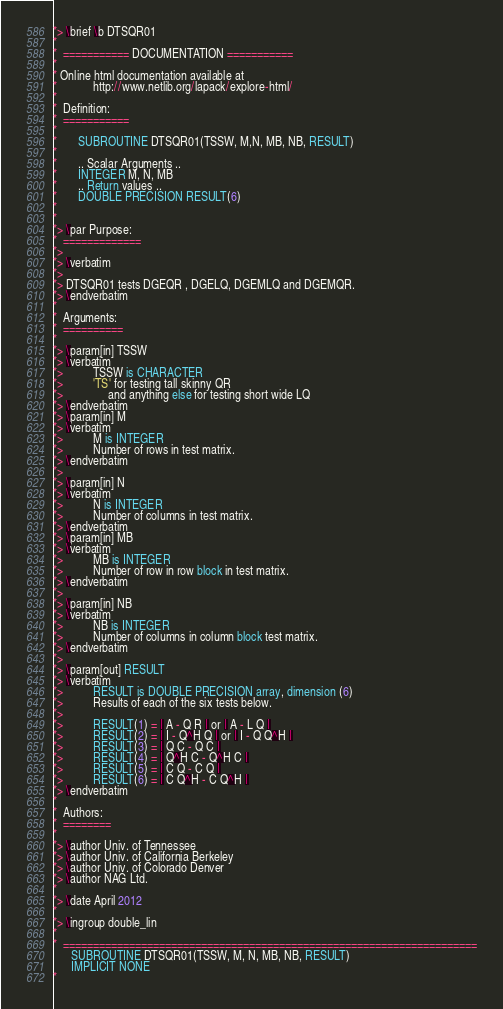Convert code to text. <code><loc_0><loc_0><loc_500><loc_500><_FORTRAN_>*> \brief \b DTSQR01
*
*  =========== DOCUMENTATION ===========
*
* Online html documentation available at
*            http://www.netlib.org/lapack/explore-html/
*
*  Definition:
*  ===========
*
*       SUBROUTINE DTSQR01(TSSW, M,N, MB, NB, RESULT)
*
*       .. Scalar Arguments ..
*       INTEGER M, N, MB
*       .. Return values ..
*       DOUBLE PRECISION RESULT(6)
*
*
*> \par Purpose:
*  =============
*>
*> \verbatim
*>
*> DTSQR01 tests DGEQR , DGELQ, DGEMLQ and DGEMQR.
*> \endverbatim
*
*  Arguments:
*  ==========
*
*> \param[in] TSSW
*> \verbatim
*>          TSSW is CHARACTER
*>          'TS' for testing tall skinny QR
*>               and anything else for testing short wide LQ
*> \endverbatim
*> \param[in] M
*> \verbatim
*>          M is INTEGER
*>          Number of rows in test matrix.
*> \endverbatim
*>
*> \param[in] N
*> \verbatim
*>          N is INTEGER
*>          Number of columns in test matrix.
*> \endverbatim
*> \param[in] MB
*> \verbatim
*>          MB is INTEGER
*>          Number of row in row block in test matrix.
*> \endverbatim
*>
*> \param[in] NB
*> \verbatim
*>          NB is INTEGER
*>          Number of columns in column block test matrix.
*> \endverbatim
*>
*> \param[out] RESULT
*> \verbatim
*>          RESULT is DOUBLE PRECISION array, dimension (6)
*>          Results of each of the six tests below.
*>
*>          RESULT(1) = | A - Q R | or | A - L Q |
*>          RESULT(2) = | I - Q^H Q | or | I - Q Q^H |
*>          RESULT(3) = | Q C - Q C |
*>          RESULT(4) = | Q^H C - Q^H C |
*>          RESULT(5) = | C Q - C Q |
*>          RESULT(6) = | C Q^H - C Q^H |
*> \endverbatim
*
*  Authors:
*  ========
*
*> \author Univ. of Tennessee
*> \author Univ. of California Berkeley
*> \author Univ. of Colorado Denver
*> \author NAG Ltd.
*
*> \date April 2012
*
*> \ingroup double_lin
*
*  =====================================================================
      SUBROUTINE DTSQR01(TSSW, M, N, MB, NB, RESULT)
      IMPLICIT NONE
*</code> 